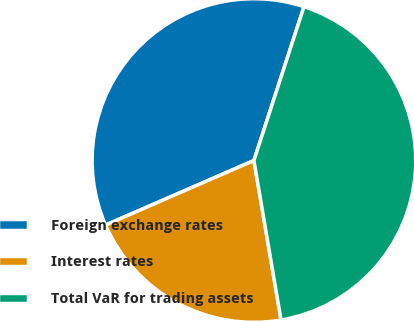Convert chart to OTSL. <chart><loc_0><loc_0><loc_500><loc_500><pie_chart><fcel>Foreign exchange rates<fcel>Interest rates<fcel>Total VaR for trading assets<nl><fcel>36.54%<fcel>21.15%<fcel>42.31%<nl></chart> 